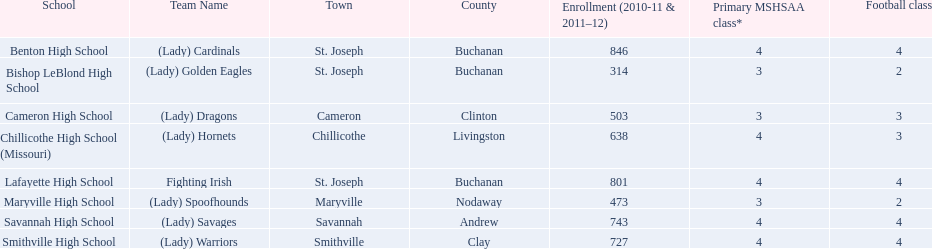What is the enrollment number for each school? Benton High School, 846, Bishop LeBlond High School, 314, Cameron High School, 503, Chillicothe High School (Missouri), 638, Lafayette High School, 801, Maryville High School, 473, Savannah High School, 743, Smithville High School, 727. Which educational institution offers a minimum of three football courses? Cameron High School, 3, Chillicothe High School (Missouri), 3. Which school has both 638 students and three football classes? Chillicothe High School (Missouri). 